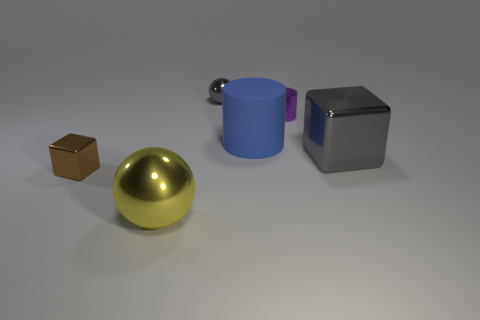Add 2 big blue shiny blocks. How many objects exist? 8 Subtract all spheres. How many objects are left? 4 Subtract all gray shiny cubes. Subtract all big yellow metallic balls. How many objects are left? 4 Add 3 purple metal objects. How many purple metal objects are left? 4 Add 5 big blue blocks. How many big blue blocks exist? 5 Subtract 0 green balls. How many objects are left? 6 